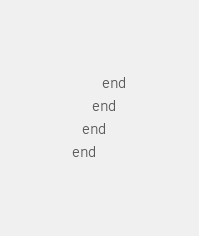Convert code to text. <code><loc_0><loc_0><loc_500><loc_500><_Ruby_>      end
    end
  end
end
</code> 